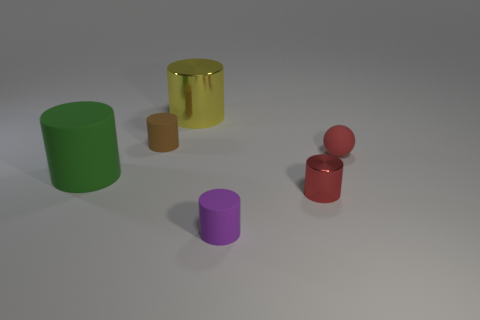What can you infer about the environment in which these cylinders are placed? The cylinders are placed in a simple, uncluttered environment with a uniform, flat surface that appears to be a studio setting. This neutral background is ideal for highlighting the objects without any distractions, suggesting a controlled lighting condition often used in product photography or 3D renderings. 